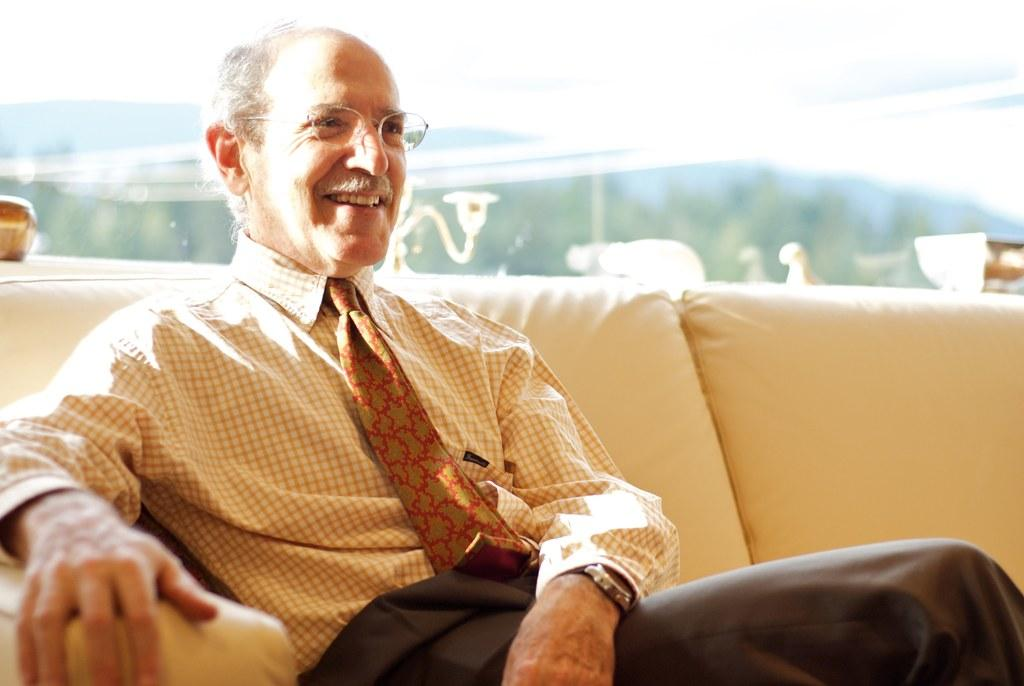What is the main subject in the foreground of the picture? There is a person sitting on a couch in the foreground of the picture. What can be seen in the background of the picture? There are trees, hills, and a railing in the background of the picture. What type of plant is growing on the railing in the image? There is no plant growing on the railing in the image. How many roses can be seen on the person sitting on the couch? There are no roses visible on the person sitting on the couch in the image. 